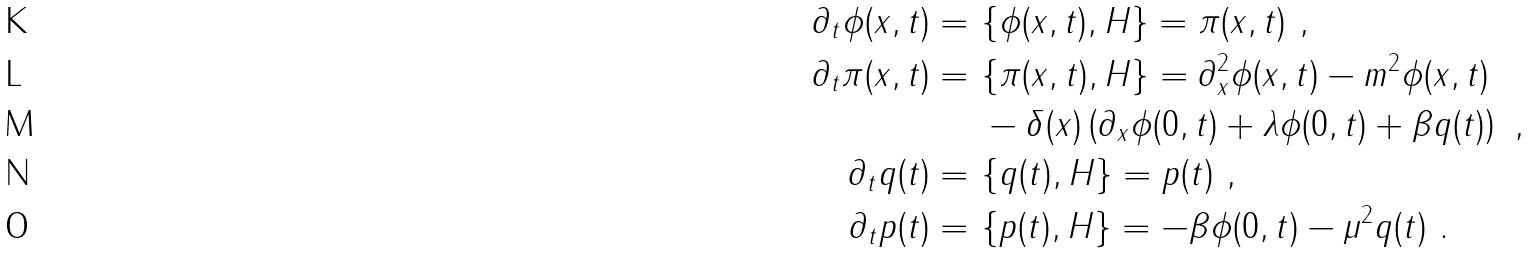<formula> <loc_0><loc_0><loc_500><loc_500>\partial _ { t } \phi ( x , t ) = & \ \{ \phi ( x , t ) , H \} = \pi ( x , t ) \ , \\ \partial _ { t } \pi ( x , t ) = & \ \{ \pi ( x , t ) , H \} = \partial _ { x } ^ { 2 } \phi ( x , t ) - m ^ { 2 } \phi ( x , t ) \\ & \ - \delta ( x ) \left ( \partial _ { x } \phi ( 0 , t ) + \lambda \phi ( 0 , t ) + \beta q ( t ) \right ) \ , \\ \partial _ { t } q ( t ) = & \ \{ q ( t ) , H \} = p ( t ) \ , \\ \partial _ { t } p ( t ) = & \ \{ p ( t ) , H \} = - \beta \phi ( 0 , t ) - \mu ^ { 2 } q ( t ) \ .</formula> 